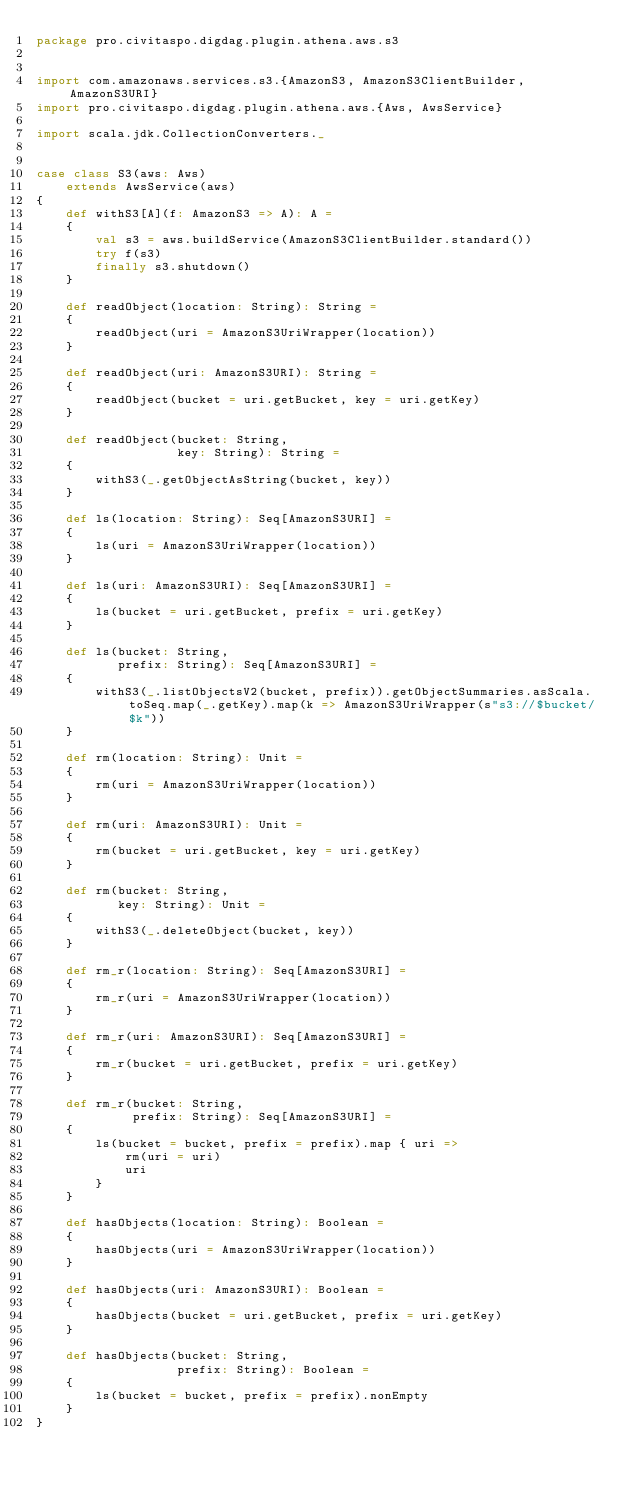Convert code to text. <code><loc_0><loc_0><loc_500><loc_500><_Scala_>package pro.civitaspo.digdag.plugin.athena.aws.s3


import com.amazonaws.services.s3.{AmazonS3, AmazonS3ClientBuilder, AmazonS3URI}
import pro.civitaspo.digdag.plugin.athena.aws.{Aws, AwsService}

import scala.jdk.CollectionConverters._


case class S3(aws: Aws)
    extends AwsService(aws)
{
    def withS3[A](f: AmazonS3 => A): A =
    {
        val s3 = aws.buildService(AmazonS3ClientBuilder.standard())
        try f(s3)
        finally s3.shutdown()
    }

    def readObject(location: String): String =
    {
        readObject(uri = AmazonS3UriWrapper(location))
    }

    def readObject(uri: AmazonS3URI): String =
    {
        readObject(bucket = uri.getBucket, key = uri.getKey)
    }

    def readObject(bucket: String,
                   key: String): String =
    {
        withS3(_.getObjectAsString(bucket, key))
    }

    def ls(location: String): Seq[AmazonS3URI] =
    {
        ls(uri = AmazonS3UriWrapper(location))
    }

    def ls(uri: AmazonS3URI): Seq[AmazonS3URI] =
    {
        ls(bucket = uri.getBucket, prefix = uri.getKey)
    }

    def ls(bucket: String,
           prefix: String): Seq[AmazonS3URI] =
    {
        withS3(_.listObjectsV2(bucket, prefix)).getObjectSummaries.asScala.toSeq.map(_.getKey).map(k => AmazonS3UriWrapper(s"s3://$bucket/$k"))
    }

    def rm(location: String): Unit =
    {
        rm(uri = AmazonS3UriWrapper(location))
    }

    def rm(uri: AmazonS3URI): Unit =
    {
        rm(bucket = uri.getBucket, key = uri.getKey)
    }

    def rm(bucket: String,
           key: String): Unit =
    {
        withS3(_.deleteObject(bucket, key))
    }

    def rm_r(location: String): Seq[AmazonS3URI] =
    {
        rm_r(uri = AmazonS3UriWrapper(location))
    }

    def rm_r(uri: AmazonS3URI): Seq[AmazonS3URI] =
    {
        rm_r(bucket = uri.getBucket, prefix = uri.getKey)
    }

    def rm_r(bucket: String,
             prefix: String): Seq[AmazonS3URI] =
    {
        ls(bucket = bucket, prefix = prefix).map { uri =>
            rm(uri = uri)
            uri
        }
    }

    def hasObjects(location: String): Boolean =
    {
        hasObjects(uri = AmazonS3UriWrapper(location))
    }

    def hasObjects(uri: AmazonS3URI): Boolean =
    {
        hasObjects(bucket = uri.getBucket, prefix = uri.getKey)
    }

    def hasObjects(bucket: String,
                   prefix: String): Boolean =
    {
        ls(bucket = bucket, prefix = prefix).nonEmpty
    }
}
</code> 